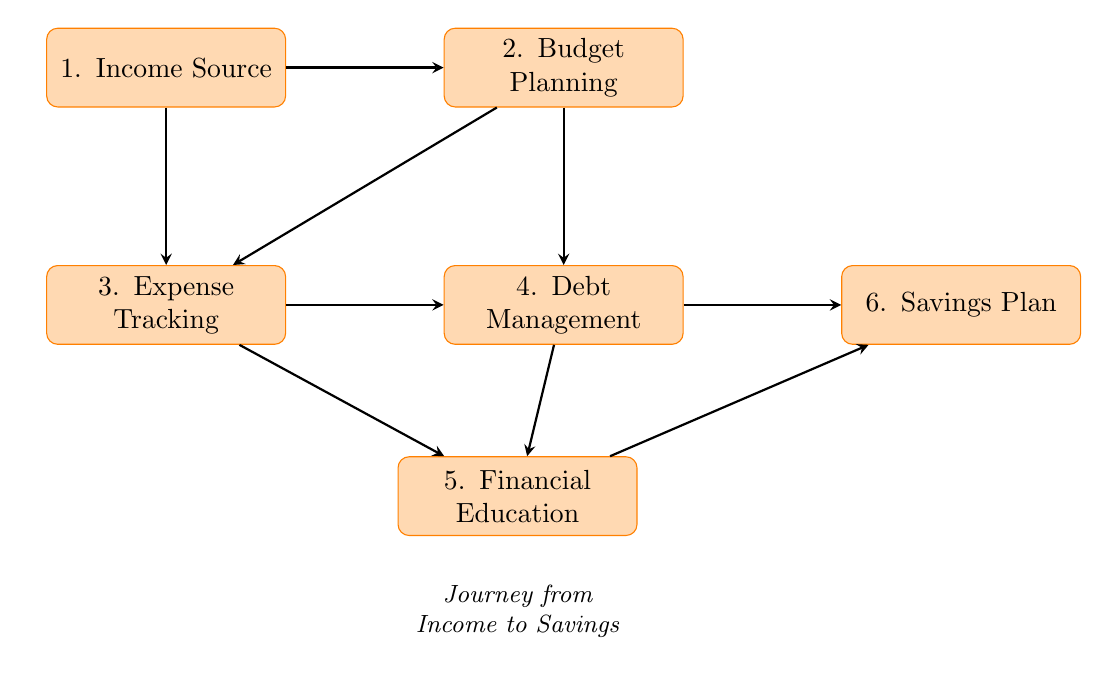What is the first step in the journey from income to savings? The first step indicated in the diagram is "Income Source," which serves as the starting point for the journey.
Answer: Income Source How many nodes are in the flow chart? The flow chart contains six nodes, as represented in the diagram which outlines different steps in the financial literacy journey.
Answer: 6 What is the relationship between Budget Planning and Debt Management? Budget Planning directly leads to Debt Management, as indicated by the arrow connecting these two nodes in the flow.
Answer: Leads to Which action is part of the Expense Tracking node? The action “Keep Receipts” is listed under the Expense Tracking node in the diagram, highlighting one of the methods to monitor expenses.
Answer: Keep Receipts Which nodes connect directly to the Savings Plan? The Savings Plan is connected directly by arrows from both Debt Management and Financial Education in the diagram, indicating that these steps contribute to savings.
Answer: Debt Management, Financial Education Which node follows directly after Expense Tracking? Debt Management follows directly after Expense Tracking in the flow chart, reflecting the progression from tracking expenses to managing debt.
Answer: Debt Management What is one action under Financial Education? One action listed under Financial Education is “Attend Workshops,” showing a method for gaining financial literacy.
Answer: Attend Workshops Explain the flow from Income Source to Savings Plan. The flow begins at Income Source, which leads to Budget Planning. From there, Expense Tracking can happen while simultaneously connecting to Debt Management. Finally, Financial Education contributes to the Savings Plan along with Debt Management, creating a comprehensive pathway to savings.
Answer: Income Source → Budget Planning → Expense Tracking/Debt Management → Financial Education/Debt Management → Savings Plan What is the last node in this journey? The last node in the journey outlined is the Savings Plan, representing the ultimate goal after following previous steps.
Answer: Savings Plan 